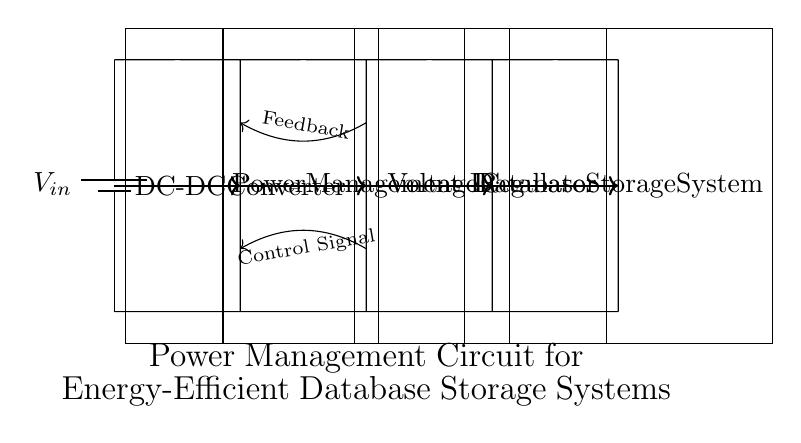What is the main purpose of the circuit? The main purpose of the circuit is to manage power efficiently for a database storage system, facilitating energy savings during operation.
Answer: Power management What components are included in the circuit? The circuit includes a battery, a DC-DC converter, a power management IC, a voltage regulator, and a database storage system.
Answer: Battery, DC-DC converter, Power Management IC, Voltage Regulator, Database Storage System How many main blocks are there in the circuit? There are four main blocks in the circuit: DC-DC converter, Power Management IC, Voltage Regulator, and Database Storage System.
Answer: Four What type of signal is used for control between the components? A control signal is used to manage the interaction between the power management IC and the DC-DC converter.
Answer: Control signal Why is feedback necessary in this circuit? Feedback is necessary to ensure the voltage levels are maintained for optimal performance and efficiency of the components, particularly the power management IC.
Answer: To maintain voltage levels Which component directly powers the database storage system? The voltage regulator directly supplies power to the database storage system, ensuring it receives the correct voltage.
Answer: Voltage regulator What is the flow direction of power in this circuit? The power flows from the battery through the DC-DC converter, then to the power management IC, followed by the voltage regulator, and finally to the database storage system.
Answer: From battery to database storage system 